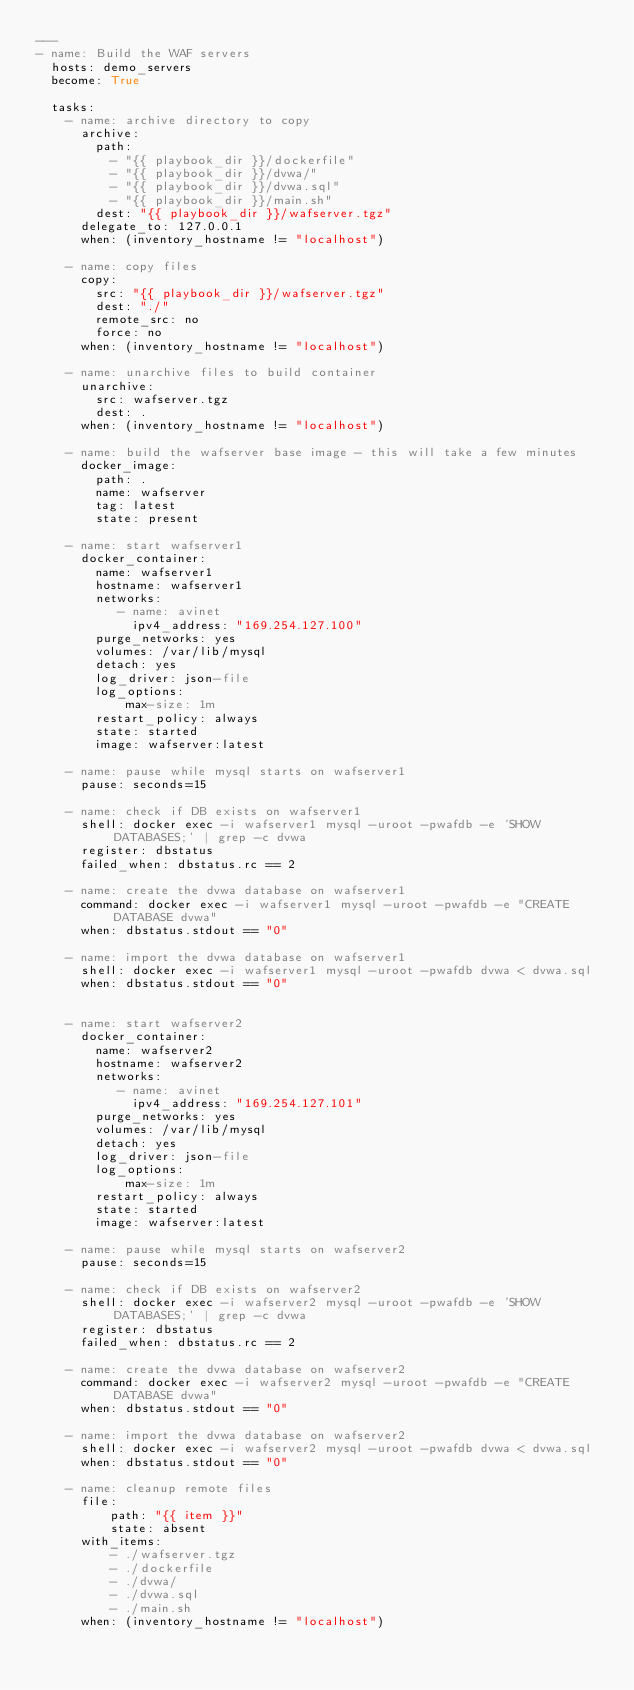Convert code to text. <code><loc_0><loc_0><loc_500><loc_500><_YAML_>---
- name: Build the WAF servers
  hosts: demo_servers
  become: True

  tasks:
    - name: archive directory to copy
      archive:
        path:
          - "{{ playbook_dir }}/dockerfile"
          - "{{ playbook_dir }}/dvwa/"
          - "{{ playbook_dir }}/dvwa.sql"
          - "{{ playbook_dir }}/main.sh"
        dest: "{{ playbook_dir }}/wafserver.tgz"
      delegate_to: 127.0.0.1
      when: (inventory_hostname != "localhost")

    - name: copy files
      copy:
        src: "{{ playbook_dir }}/wafserver.tgz"
        dest: "./"
        remote_src: no
        force: no
      when: (inventory_hostname != "localhost")

    - name: unarchive files to build container
      unarchive:
        src: wafserver.tgz
        dest: .
      when: (inventory_hostname != "localhost")

    - name: build the wafserver base image - this will take a few minutes
      docker_image:
        path: .
        name: wafserver
        tag: latest
        state: present

    - name: start wafserver1
      docker_container:
        name: wafserver1
        hostname: wafserver1
        networks:
           - name: avinet
             ipv4_address: "169.254.127.100"
        purge_networks: yes
        volumes: /var/lib/mysql
        detach: yes
        log_driver: json-file
        log_options:
            max-size: 1m
        restart_policy: always
        state: started
        image: wafserver:latest

    - name: pause while mysql starts on wafserver1
      pause: seconds=15

    - name: check if DB exists on wafserver1
      shell: docker exec -i wafserver1 mysql -uroot -pwafdb -e 'SHOW DATABASES;' | grep -c dvwa
      register: dbstatus
      failed_when: dbstatus.rc == 2

    - name: create the dvwa database on wafserver1
      command: docker exec -i wafserver1 mysql -uroot -pwafdb -e "CREATE DATABASE dvwa"
      when: dbstatus.stdout == "0"

    - name: import the dvwa database on wafserver1
      shell: docker exec -i wafserver1 mysql -uroot -pwafdb dvwa < dvwa.sql
      when: dbstatus.stdout == "0"


    - name: start wafserver2
      docker_container:
        name: wafserver2
        hostname: wafserver2
        networks:
           - name: avinet
             ipv4_address: "169.254.127.101"
        purge_networks: yes
        volumes: /var/lib/mysql
        detach: yes
        log_driver: json-file
        log_options:
            max-size: 1m
        restart_policy: always
        state: started
        image: wafserver:latest

    - name: pause while mysql starts on wafserver2
      pause: seconds=15

    - name: check if DB exists on wafserver2
      shell: docker exec -i wafserver2 mysql -uroot -pwafdb -e 'SHOW DATABASES;' | grep -c dvwa
      register: dbstatus
      failed_when: dbstatus.rc == 2

    - name: create the dvwa database on wafserver2
      command: docker exec -i wafserver2 mysql -uroot -pwafdb -e "CREATE DATABASE dvwa"
      when: dbstatus.stdout == "0"

    - name: import the dvwa database on wafserver2
      shell: docker exec -i wafserver2 mysql -uroot -pwafdb dvwa < dvwa.sql
      when: dbstatus.stdout == "0"

    - name: cleanup remote files
      file:
          path: "{{ item }}"
          state: absent
      with_items:
          - ./wafserver.tgz
          - ./dockerfile
          - ./dvwa/
          - ./dvwa.sql
          - ./main.sh
      when: (inventory_hostname != "localhost")
</code> 